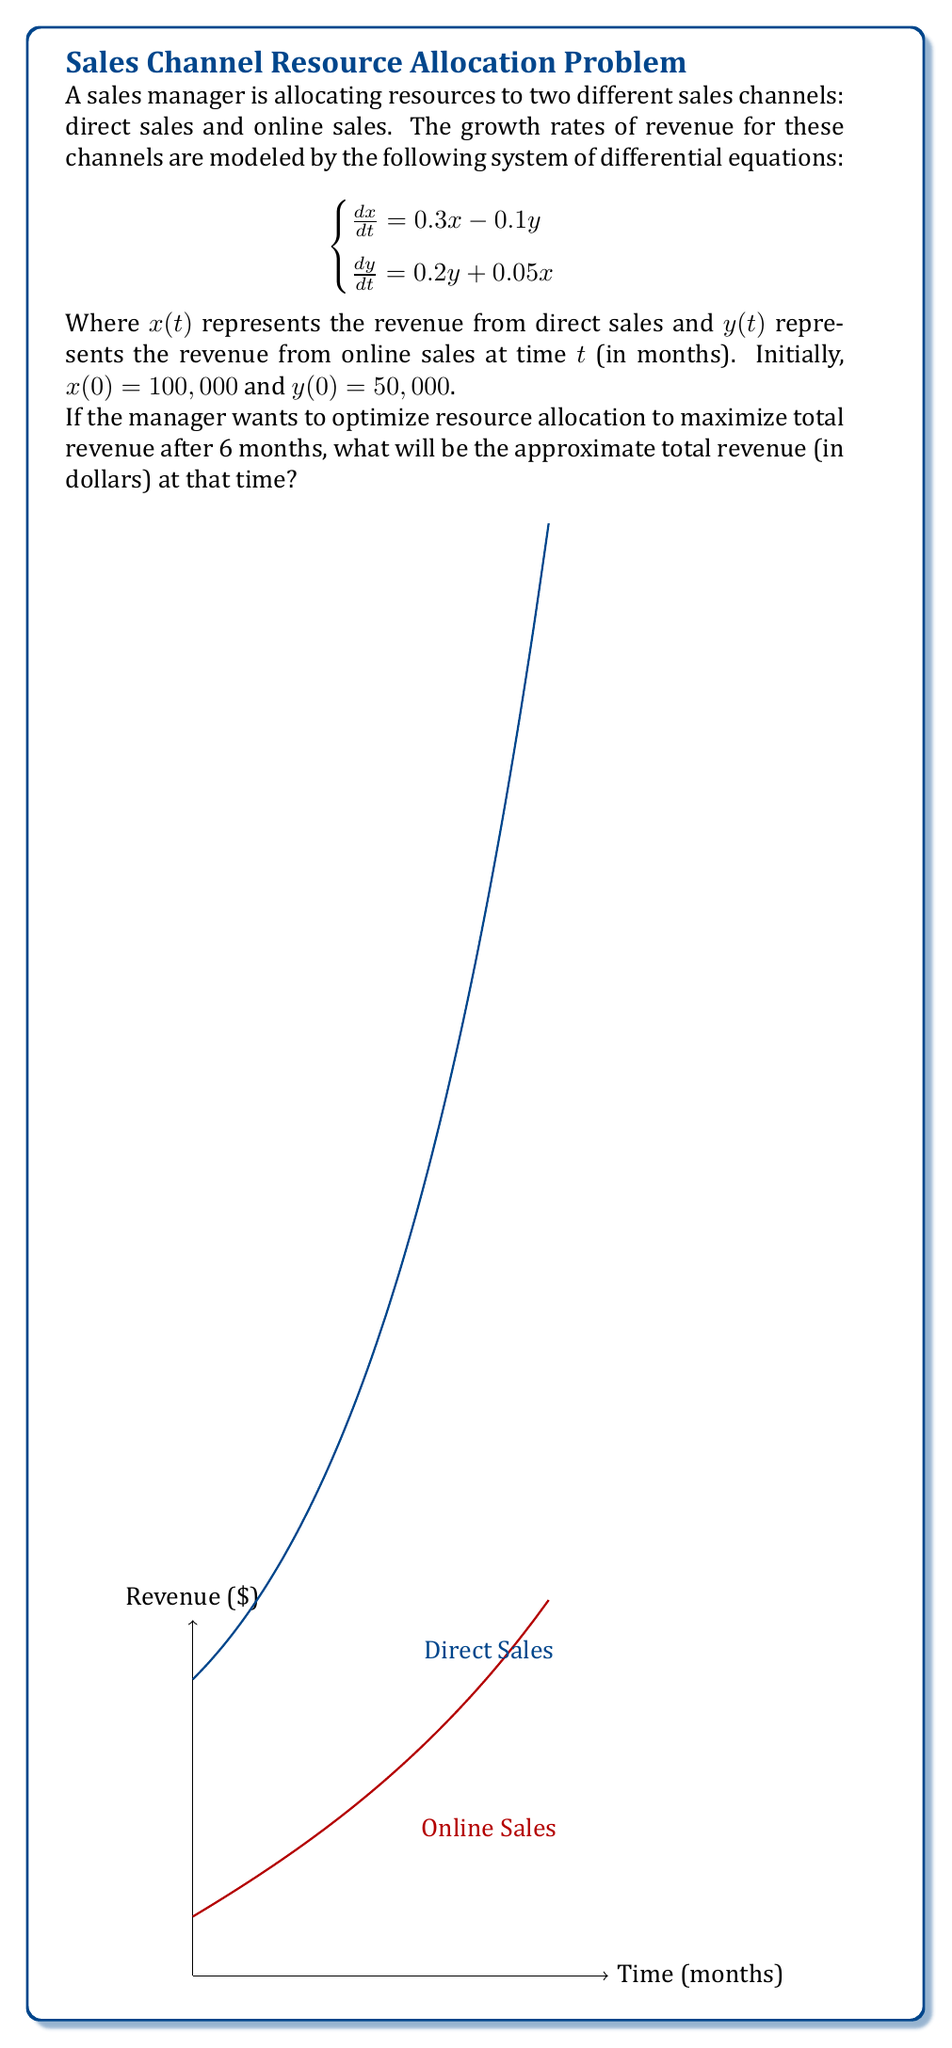Teach me how to tackle this problem. To solve this problem, we need to follow these steps:

1) First, we need to solve the system of differential equations. The general solution for this type of system is of the form:

   $$\begin{bmatrix} x \\ y \end{bmatrix} = c_1e^{\lambda_1t}\mathbf{v_1} + c_2e^{\lambda_2t}\mathbf{v_2}$$

   where $\lambda_1, \lambda_2$ are eigenvalues and $\mathbf{v_1}, \mathbf{v_2}$ are corresponding eigenvectors.

2) The characteristic equation is:
   
   $$\det\begin{pmatrix} 0.3-\lambda & -0.1 \\ 0.05 & 0.2-\lambda \end{pmatrix} = 0$$

   $$\lambda^2 - 0.5\lambda + 0.05 = 0$$

3) Solving this, we get $\lambda_1 = 0.3$ and $\lambda_2 = -0.2$

4) The corresponding eigenvectors are:
   
   $$\mathbf{v_1} = \begin{bmatrix} 1 \\ 0.5 \end{bmatrix}, \mathbf{v_2} = \begin{bmatrix} 1 \\ -1 \end{bmatrix}$$

5) The general solution is:

   $$\begin{bmatrix} x \\ y \end{bmatrix} = c_1e^{0.3t}\begin{bmatrix} 1 \\ 0.5 \end{bmatrix} + c_2e^{-0.2t}\begin{bmatrix} 1 \\ -1 \end{bmatrix}$$

6) Using the initial conditions, we can find $c_1$ and $c_2$:

   $$100,000 = c_1 + c_2$$
   $$50,000 = 0.5c_1 - c_2$$

   Solving these, we get $c_1 = 100,000$ and $c_2 = 25,000$

7) Therefore, the solution is:

   $$x(t) = 100,000e^{0.3t} + 25,000e^{-0.2t}$$
   $$y(t) = 50,000e^{0.3t} - 25,000e^{-0.2t}$$

8) At $t = 6$ months:

   $$x(6) \approx 100,000 \cdot 6.0496 + 25,000 \cdot 0.3012 \approx 612,710$$
   $$y(6) \approx 50,000 \cdot 6.0496 - 25,000 \cdot 0.3012 \approx 295,210$$

9) The total revenue is the sum of $x(6)$ and $y(6)$:

   $$612,710 + 295,210 = 907,920$$
Answer: $907,920 